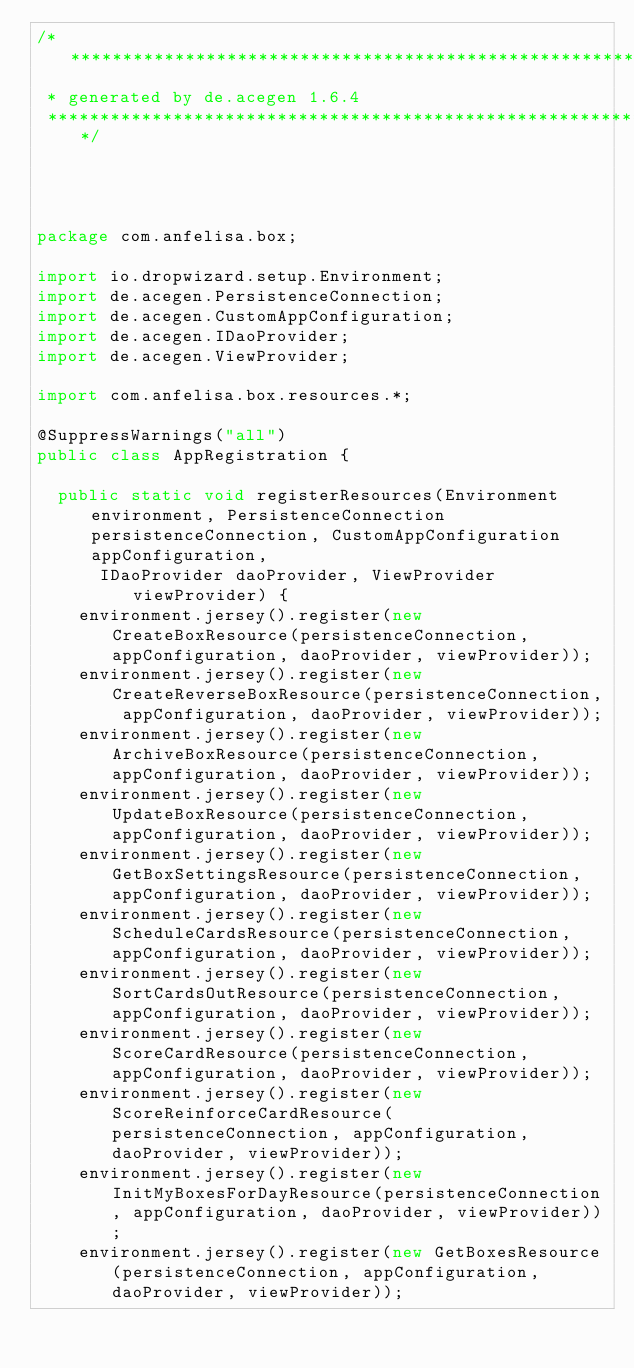<code> <loc_0><loc_0><loc_500><loc_500><_Java_>/********************************************************************************
 * generated by de.acegen 1.6.4
 ********************************************************************************/




package com.anfelisa.box;

import io.dropwizard.setup.Environment;
import de.acegen.PersistenceConnection;
import de.acegen.CustomAppConfiguration;
import de.acegen.IDaoProvider;
import de.acegen.ViewProvider;

import com.anfelisa.box.resources.*;

@SuppressWarnings("all")
public class AppRegistration {

	public static void registerResources(Environment environment, PersistenceConnection persistenceConnection, CustomAppConfiguration appConfiguration, 
			IDaoProvider daoProvider, ViewProvider viewProvider) {
		environment.jersey().register(new CreateBoxResource(persistenceConnection, appConfiguration, daoProvider, viewProvider));
		environment.jersey().register(new CreateReverseBoxResource(persistenceConnection, appConfiguration, daoProvider, viewProvider));
		environment.jersey().register(new ArchiveBoxResource(persistenceConnection, appConfiguration, daoProvider, viewProvider));
		environment.jersey().register(new UpdateBoxResource(persistenceConnection, appConfiguration, daoProvider, viewProvider));
		environment.jersey().register(new GetBoxSettingsResource(persistenceConnection, appConfiguration, daoProvider, viewProvider));
		environment.jersey().register(new ScheduleCardsResource(persistenceConnection, appConfiguration, daoProvider, viewProvider));
		environment.jersey().register(new SortCardsOutResource(persistenceConnection, appConfiguration, daoProvider, viewProvider));
		environment.jersey().register(new ScoreCardResource(persistenceConnection, appConfiguration, daoProvider, viewProvider));
		environment.jersey().register(new ScoreReinforceCardResource(persistenceConnection, appConfiguration, daoProvider, viewProvider));
		environment.jersey().register(new InitMyBoxesForDayResource(persistenceConnection, appConfiguration, daoProvider, viewProvider));
		environment.jersey().register(new GetBoxesResource(persistenceConnection, appConfiguration, daoProvider, viewProvider));</code> 